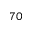<formula> <loc_0><loc_0><loc_500><loc_500>_ { 7 0 }</formula> 